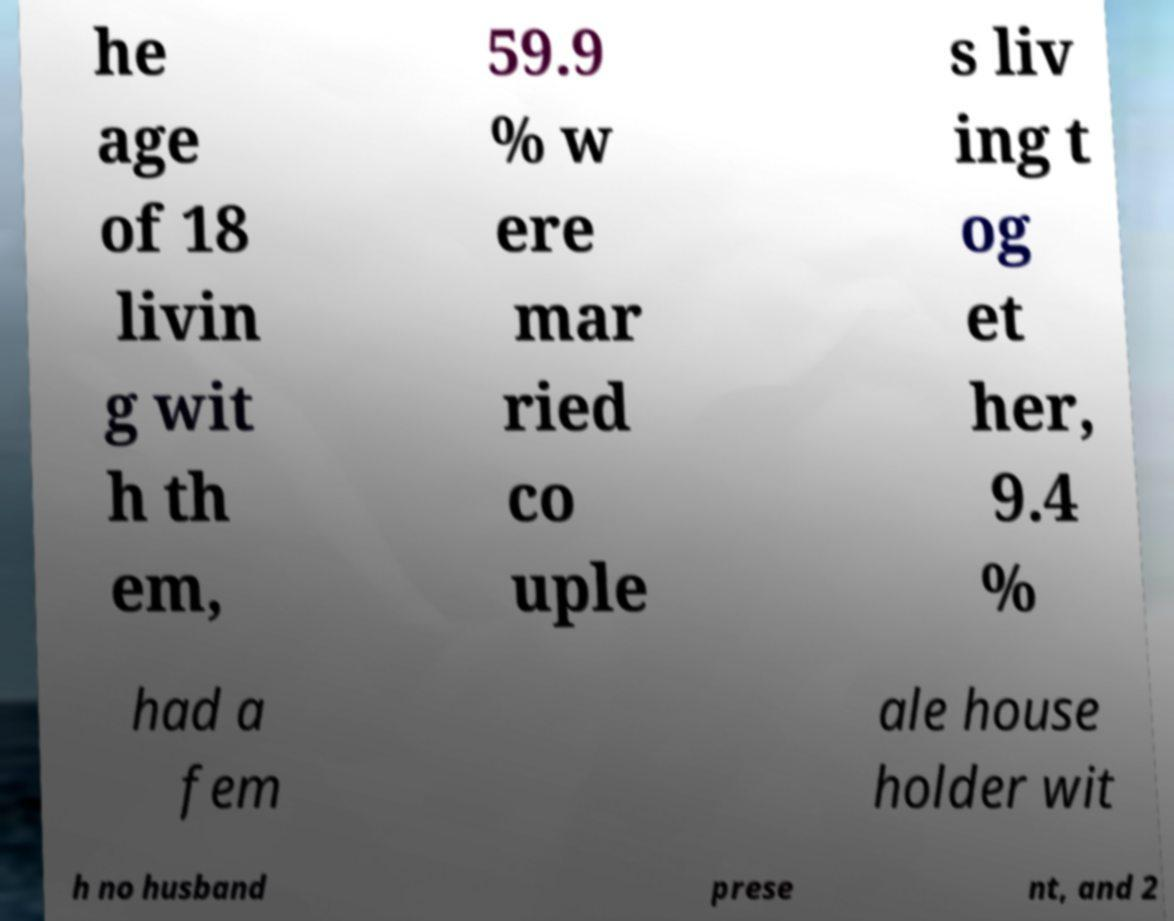For documentation purposes, I need the text within this image transcribed. Could you provide that? he age of 18 livin g wit h th em, 59.9 % w ere mar ried co uple s liv ing t og et her, 9.4 % had a fem ale house holder wit h no husband prese nt, and 2 